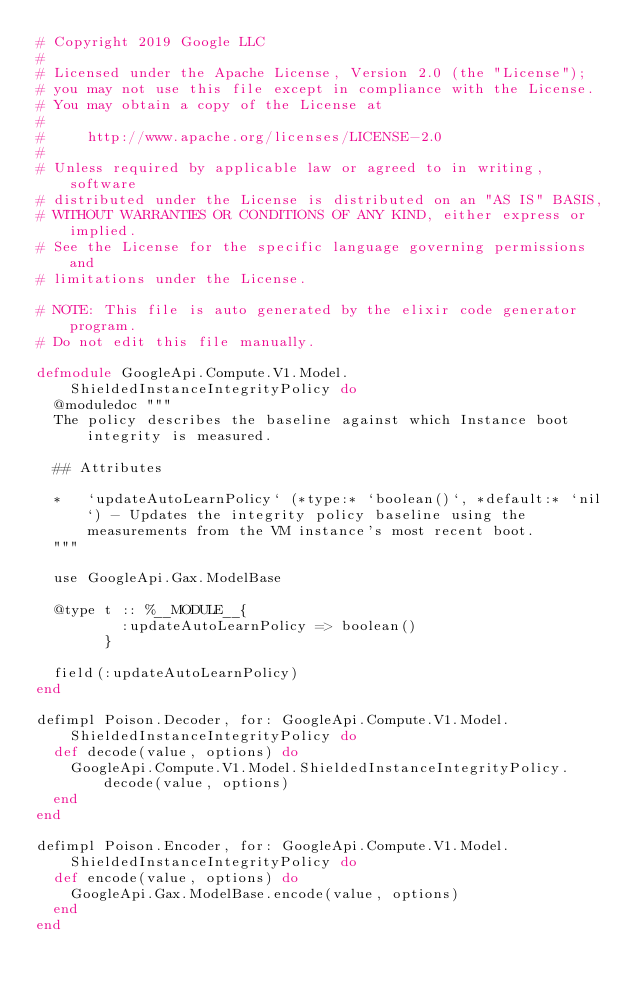Convert code to text. <code><loc_0><loc_0><loc_500><loc_500><_Elixir_># Copyright 2019 Google LLC
#
# Licensed under the Apache License, Version 2.0 (the "License");
# you may not use this file except in compliance with the License.
# You may obtain a copy of the License at
#
#     http://www.apache.org/licenses/LICENSE-2.0
#
# Unless required by applicable law or agreed to in writing, software
# distributed under the License is distributed on an "AS IS" BASIS,
# WITHOUT WARRANTIES OR CONDITIONS OF ANY KIND, either express or implied.
# See the License for the specific language governing permissions and
# limitations under the License.

# NOTE: This file is auto generated by the elixir code generator program.
# Do not edit this file manually.

defmodule GoogleApi.Compute.V1.Model.ShieldedInstanceIntegrityPolicy do
  @moduledoc """
  The policy describes the baseline against which Instance boot integrity is measured.

  ## Attributes

  *   `updateAutoLearnPolicy` (*type:* `boolean()`, *default:* `nil`) - Updates the integrity policy baseline using the measurements from the VM instance's most recent boot.
  """

  use GoogleApi.Gax.ModelBase

  @type t :: %__MODULE__{
          :updateAutoLearnPolicy => boolean()
        }

  field(:updateAutoLearnPolicy)
end

defimpl Poison.Decoder, for: GoogleApi.Compute.V1.Model.ShieldedInstanceIntegrityPolicy do
  def decode(value, options) do
    GoogleApi.Compute.V1.Model.ShieldedInstanceIntegrityPolicy.decode(value, options)
  end
end

defimpl Poison.Encoder, for: GoogleApi.Compute.V1.Model.ShieldedInstanceIntegrityPolicy do
  def encode(value, options) do
    GoogleApi.Gax.ModelBase.encode(value, options)
  end
end
</code> 